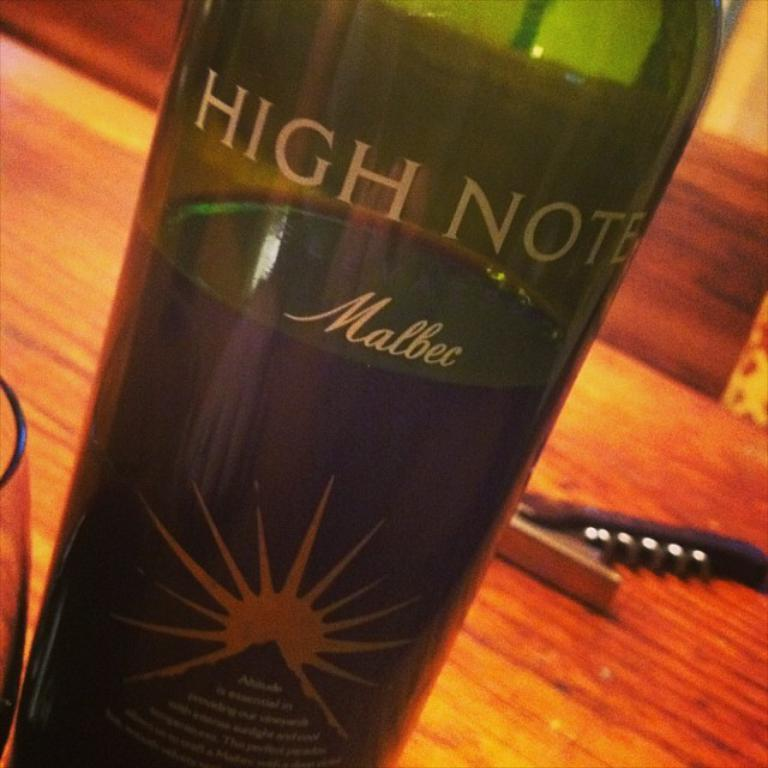<image>
Describe the image concisely. a bottle of high note Malbec wine is open and sitting on the table 